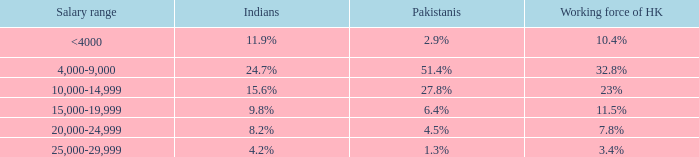If the Indians are 8.2%, what is the salary range? 20,000-24,999. 